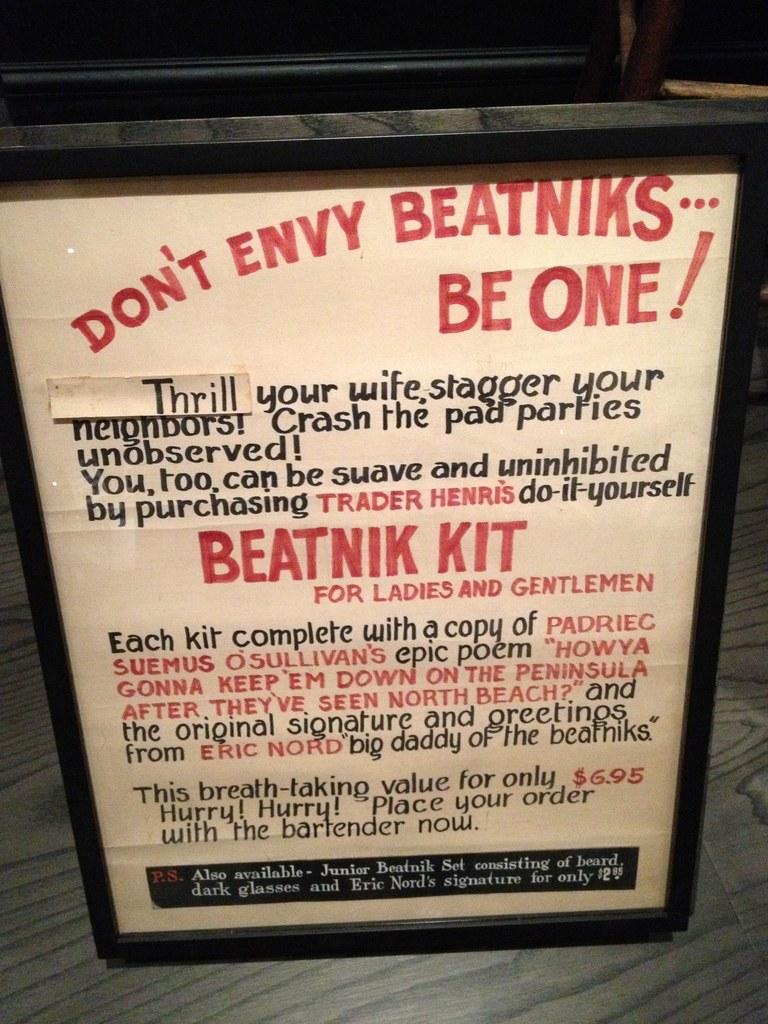Provide a one-sentence caption for the provided image. A sign that starts "Don't envy the beatniks...be one!". 